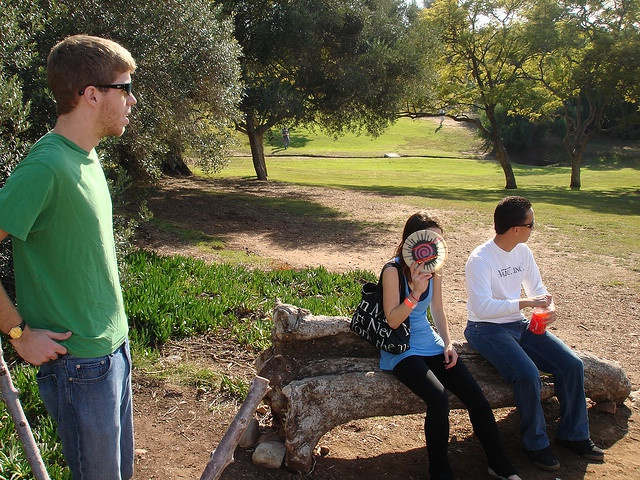Describe the objects in this image and their specific colors. I can see people in maroon, darkgreen, teal, black, and gray tones, people in maroon, black, lavender, navy, and darkgray tones, people in maroon, black, gray, and blue tones, handbag in maroon, black, gray, and darkgray tones, and frisbee in maroon, darkgray, black, brown, and gray tones in this image. 